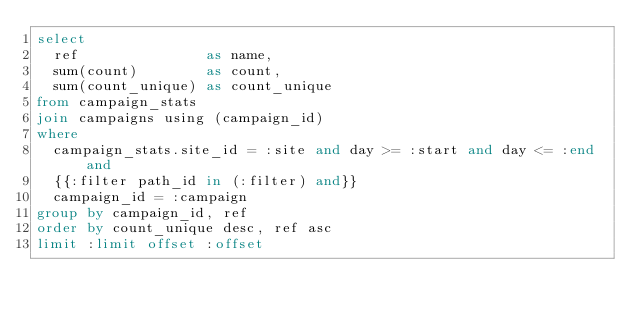<code> <loc_0><loc_0><loc_500><loc_500><_SQL_>select
	ref               as name,
	sum(count)        as count,
	sum(count_unique) as count_unique
from campaign_stats
join campaigns using (campaign_id)
where
	campaign_stats.site_id = :site and day >= :start and day <= :end and
	{{:filter path_id in (:filter) and}}
	campaign_id = :campaign
group by campaign_id, ref
order by count_unique desc, ref asc
limit :limit offset :offset
</code> 